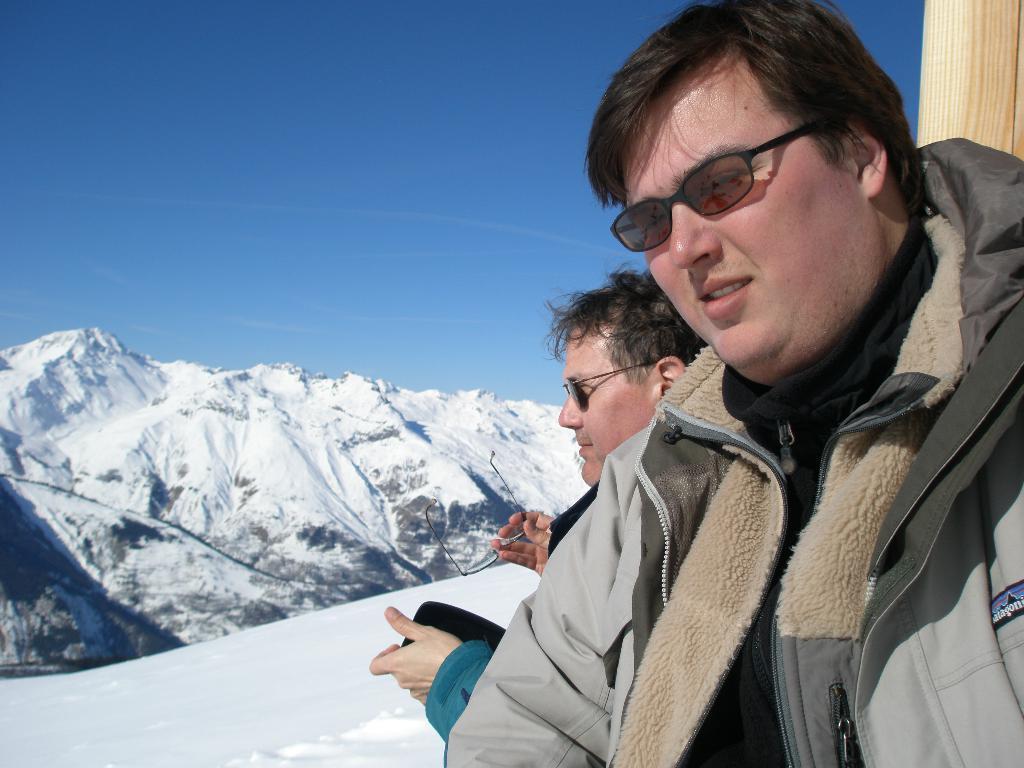How would you summarize this image in a sentence or two? This picture is clicked outside. On the right we can see the two persons. In the background we can see the sky, hills and we can see the spectacles and lot of snow. 